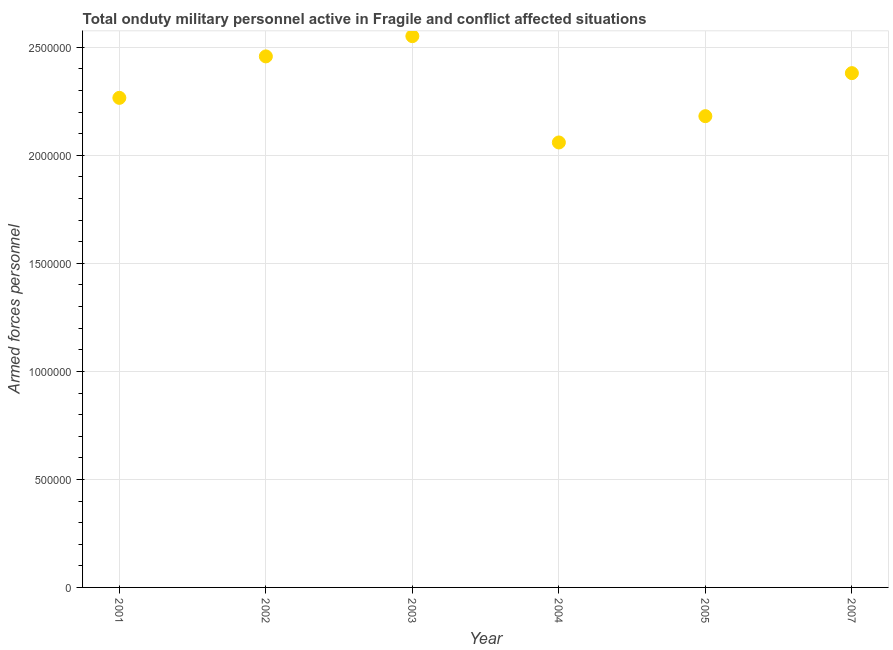What is the number of armed forces personnel in 2007?
Keep it short and to the point. 2.38e+06. Across all years, what is the maximum number of armed forces personnel?
Keep it short and to the point. 2.55e+06. Across all years, what is the minimum number of armed forces personnel?
Provide a succinct answer. 2.06e+06. In which year was the number of armed forces personnel maximum?
Give a very brief answer. 2003. What is the sum of the number of armed forces personnel?
Your response must be concise. 1.39e+07. What is the difference between the number of armed forces personnel in 2002 and 2007?
Provide a short and direct response. 7.75e+04. What is the average number of armed forces personnel per year?
Your answer should be very brief. 2.32e+06. What is the median number of armed forces personnel?
Provide a short and direct response. 2.32e+06. Do a majority of the years between 2003 and 2007 (inclusive) have number of armed forces personnel greater than 1700000 ?
Your response must be concise. Yes. What is the ratio of the number of armed forces personnel in 2003 to that in 2007?
Give a very brief answer. 1.07. Is the number of armed forces personnel in 2003 less than that in 2007?
Keep it short and to the point. No. Is the difference between the number of armed forces personnel in 2002 and 2007 greater than the difference between any two years?
Offer a very short reply. No. What is the difference between the highest and the second highest number of armed forces personnel?
Your answer should be very brief. 9.38e+04. What is the difference between the highest and the lowest number of armed forces personnel?
Your answer should be compact. 4.92e+05. In how many years, is the number of armed forces personnel greater than the average number of armed forces personnel taken over all years?
Offer a very short reply. 3. How many years are there in the graph?
Keep it short and to the point. 6. Are the values on the major ticks of Y-axis written in scientific E-notation?
Your answer should be compact. No. Does the graph contain any zero values?
Your answer should be compact. No. Does the graph contain grids?
Ensure brevity in your answer.  Yes. What is the title of the graph?
Provide a short and direct response. Total onduty military personnel active in Fragile and conflict affected situations. What is the label or title of the Y-axis?
Your answer should be very brief. Armed forces personnel. What is the Armed forces personnel in 2001?
Ensure brevity in your answer.  2.27e+06. What is the Armed forces personnel in 2002?
Give a very brief answer. 2.46e+06. What is the Armed forces personnel in 2003?
Your answer should be compact. 2.55e+06. What is the Armed forces personnel in 2004?
Offer a terse response. 2.06e+06. What is the Armed forces personnel in 2005?
Make the answer very short. 2.18e+06. What is the Armed forces personnel in 2007?
Keep it short and to the point. 2.38e+06. What is the difference between the Armed forces personnel in 2001 and 2002?
Offer a terse response. -1.92e+05. What is the difference between the Armed forces personnel in 2001 and 2003?
Your answer should be very brief. -2.86e+05. What is the difference between the Armed forces personnel in 2001 and 2004?
Your answer should be compact. 2.06e+05. What is the difference between the Armed forces personnel in 2001 and 2005?
Offer a terse response. 8.48e+04. What is the difference between the Armed forces personnel in 2001 and 2007?
Make the answer very short. -1.14e+05. What is the difference between the Armed forces personnel in 2002 and 2003?
Ensure brevity in your answer.  -9.38e+04. What is the difference between the Armed forces personnel in 2002 and 2004?
Make the answer very short. 3.98e+05. What is the difference between the Armed forces personnel in 2002 and 2005?
Offer a very short reply. 2.77e+05. What is the difference between the Armed forces personnel in 2002 and 2007?
Provide a short and direct response. 7.75e+04. What is the difference between the Armed forces personnel in 2003 and 2004?
Make the answer very short. 4.92e+05. What is the difference between the Armed forces personnel in 2003 and 2005?
Your response must be concise. 3.70e+05. What is the difference between the Armed forces personnel in 2003 and 2007?
Offer a terse response. 1.71e+05. What is the difference between the Armed forces personnel in 2004 and 2005?
Offer a very short reply. -1.22e+05. What is the difference between the Armed forces personnel in 2004 and 2007?
Your answer should be compact. -3.21e+05. What is the difference between the Armed forces personnel in 2005 and 2007?
Provide a succinct answer. -1.99e+05. What is the ratio of the Armed forces personnel in 2001 to that in 2002?
Your answer should be very brief. 0.92. What is the ratio of the Armed forces personnel in 2001 to that in 2003?
Provide a short and direct response. 0.89. What is the ratio of the Armed forces personnel in 2001 to that in 2004?
Your response must be concise. 1.1. What is the ratio of the Armed forces personnel in 2001 to that in 2005?
Provide a succinct answer. 1.04. What is the ratio of the Armed forces personnel in 2002 to that in 2003?
Your answer should be compact. 0.96. What is the ratio of the Armed forces personnel in 2002 to that in 2004?
Make the answer very short. 1.19. What is the ratio of the Armed forces personnel in 2002 to that in 2005?
Your answer should be compact. 1.13. What is the ratio of the Armed forces personnel in 2002 to that in 2007?
Your answer should be very brief. 1.03. What is the ratio of the Armed forces personnel in 2003 to that in 2004?
Your answer should be compact. 1.24. What is the ratio of the Armed forces personnel in 2003 to that in 2005?
Provide a succinct answer. 1.17. What is the ratio of the Armed forces personnel in 2003 to that in 2007?
Provide a short and direct response. 1.07. What is the ratio of the Armed forces personnel in 2004 to that in 2005?
Make the answer very short. 0.94. What is the ratio of the Armed forces personnel in 2004 to that in 2007?
Your answer should be compact. 0.86. What is the ratio of the Armed forces personnel in 2005 to that in 2007?
Give a very brief answer. 0.92. 